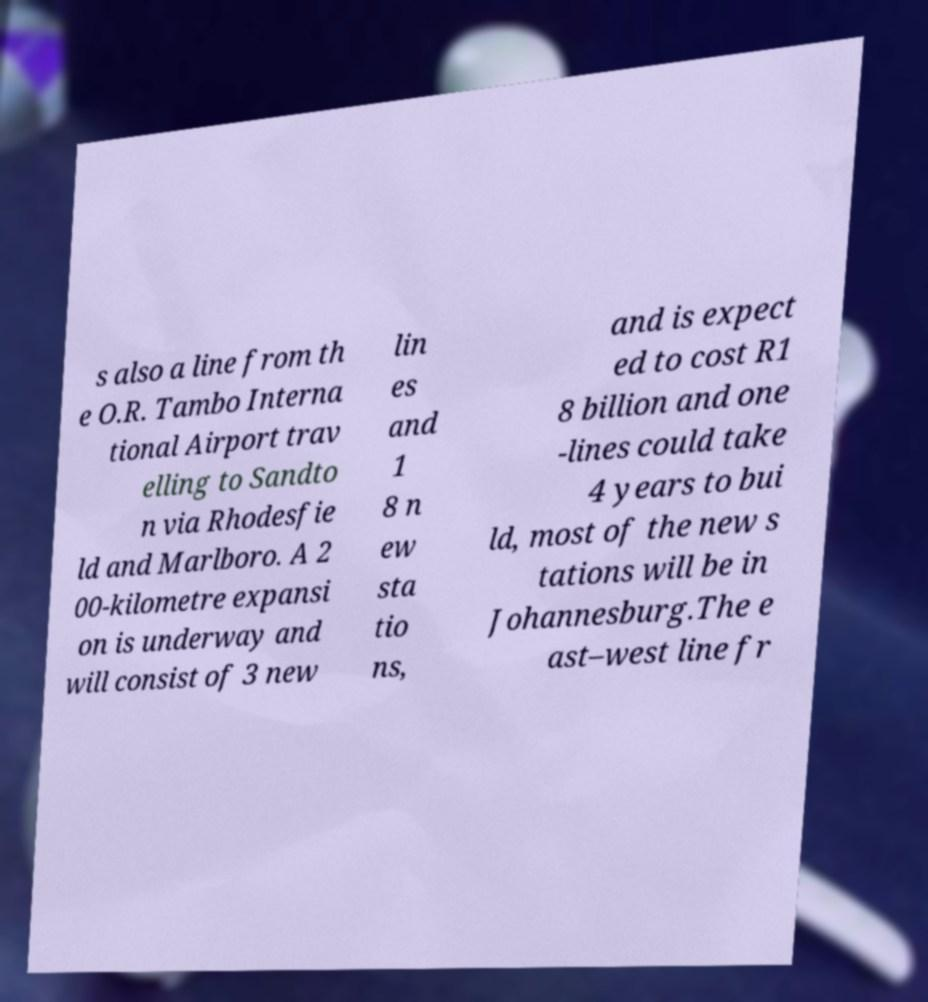Please identify and transcribe the text found in this image. s also a line from th e O.R. Tambo Interna tional Airport trav elling to Sandto n via Rhodesfie ld and Marlboro. A 2 00-kilometre expansi on is underway and will consist of 3 new lin es and 1 8 n ew sta tio ns, and is expect ed to cost R1 8 billion and one -lines could take 4 years to bui ld, most of the new s tations will be in Johannesburg.The e ast–west line fr 